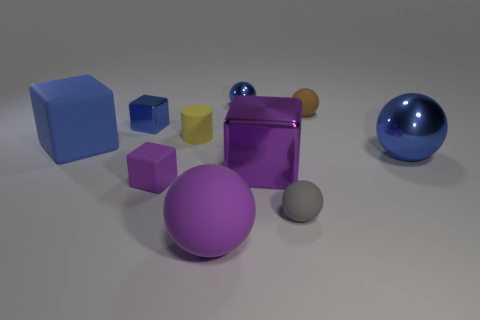Subtract 2 cubes. How many cubes are left? 2 Add 1 purple blocks. How many purple blocks exist? 3 Subtract all purple balls. How many balls are left? 4 Subtract all tiny matte balls. How many balls are left? 3 Subtract 2 blue spheres. How many objects are left? 8 Subtract all cubes. How many objects are left? 6 Subtract all red cylinders. Subtract all green balls. How many cylinders are left? 1 Subtract all purple cubes. How many brown cylinders are left? 0 Subtract all small brown rubber objects. Subtract all big blue spheres. How many objects are left? 8 Add 3 small blue shiny balls. How many small blue shiny balls are left? 4 